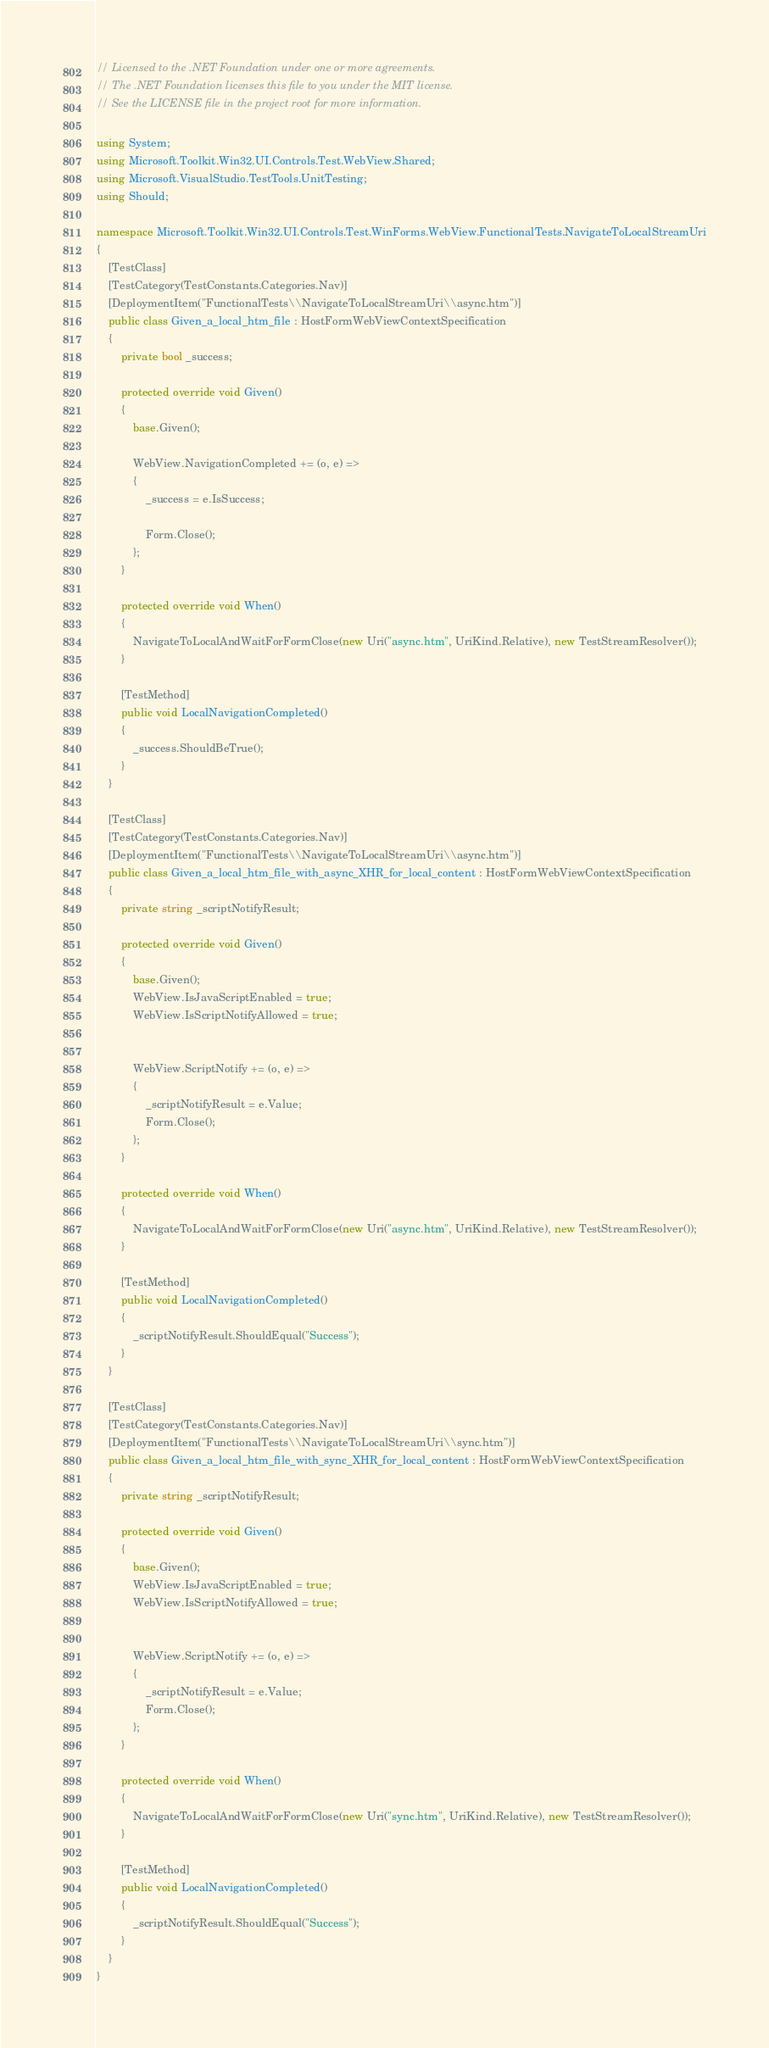Convert code to text. <code><loc_0><loc_0><loc_500><loc_500><_C#_>// Licensed to the .NET Foundation under one or more agreements.
// The .NET Foundation licenses this file to you under the MIT license.
// See the LICENSE file in the project root for more information.

using System;
using Microsoft.Toolkit.Win32.UI.Controls.Test.WebView.Shared;
using Microsoft.VisualStudio.TestTools.UnitTesting;
using Should;

namespace Microsoft.Toolkit.Win32.UI.Controls.Test.WinForms.WebView.FunctionalTests.NavigateToLocalStreamUri
{
    [TestClass]
    [TestCategory(TestConstants.Categories.Nav)]
    [DeploymentItem("FunctionalTests\\NavigateToLocalStreamUri\\async.htm")]
    public class Given_a_local_htm_file : HostFormWebViewContextSpecification
    {
        private bool _success;

        protected override void Given()
        {
            base.Given();

            WebView.NavigationCompleted += (o, e) =>
            {
                _success = e.IsSuccess;

                Form.Close();
            };
        }

        protected override void When()
        {
            NavigateToLocalAndWaitForFormClose(new Uri("async.htm", UriKind.Relative), new TestStreamResolver());
        }

        [TestMethod]
        public void LocalNavigationCompleted()
        {
            _success.ShouldBeTrue();
        }
    }

    [TestClass]
    [TestCategory(TestConstants.Categories.Nav)]
    [DeploymentItem("FunctionalTests\\NavigateToLocalStreamUri\\async.htm")]
    public class Given_a_local_htm_file_with_async_XHR_for_local_content : HostFormWebViewContextSpecification
    {
        private string _scriptNotifyResult;

        protected override void Given()
        {
            base.Given();
            WebView.IsJavaScriptEnabled = true;
            WebView.IsScriptNotifyAllowed = true;


            WebView.ScriptNotify += (o, e) =>
            {
                _scriptNotifyResult = e.Value;
                Form.Close();
            };
        }

        protected override void When()
        {
            NavigateToLocalAndWaitForFormClose(new Uri("async.htm", UriKind.Relative), new TestStreamResolver());
        }

        [TestMethod]
        public void LocalNavigationCompleted()
        {
            _scriptNotifyResult.ShouldEqual("Success");
        }
    }

    [TestClass]
    [TestCategory(TestConstants.Categories.Nav)]
    [DeploymentItem("FunctionalTests\\NavigateToLocalStreamUri\\sync.htm")]
    public class Given_a_local_htm_file_with_sync_XHR_for_local_content : HostFormWebViewContextSpecification
    {
        private string _scriptNotifyResult;

        protected override void Given()
        {
            base.Given();
            WebView.IsJavaScriptEnabled = true;
            WebView.IsScriptNotifyAllowed = true;


            WebView.ScriptNotify += (o, e) =>
            {
                _scriptNotifyResult = e.Value;
                Form.Close();
            };
        }

        protected override void When()
        {
            NavigateToLocalAndWaitForFormClose(new Uri("sync.htm", UriKind.Relative), new TestStreamResolver());
        }

        [TestMethod]
        public void LocalNavigationCompleted()
        {
            _scriptNotifyResult.ShouldEqual("Success");
        }
    }
}
</code> 